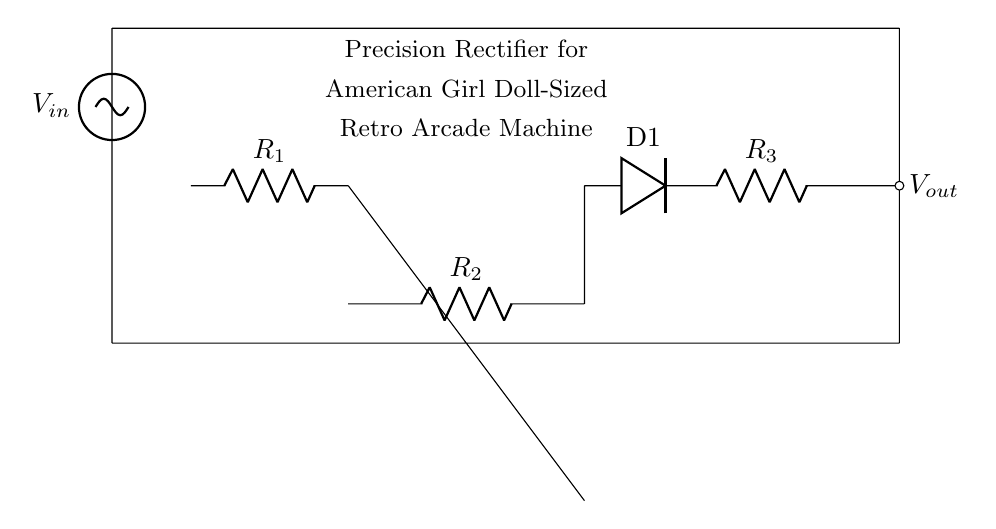What is the input voltage? The input voltage is represented by the label V_in, but the exact value is not specified in the circuit; it is just a symbol.
Answer: V_in What type of operational amplifier configuration is used? The op amp is used in a single-supply configuration since it is connected only to ground and the input voltage; it functions as a precision rectifier.
Answer: Precision rectifier How many resistors are present in the circuit? There are three resistors labeled as R_1, R_2, and R_3 directly shown in the circuit diagram.
Answer: Three What is the output voltage proportional to? The output voltage V_out is directly influenced by the input voltage V_in and the feedback components (the resistors and the diode that determine the precision of rectification).
Answer: V_in, R_1, R_2, R_3 What is the function of the diode in this circuit? The diode, labeled D1, is used to allow current to flow only in one direction, enabling rectification of the input voltage to produce a corresponding output.
Answer: Rectification What does the title indicate about the application of this circuit? The title indicates that this precision rectifier circuit is designed specifically for a retro arcade machine that is sized for American Girl dolls.
Answer: American Girl doll-sized retro arcade machine 